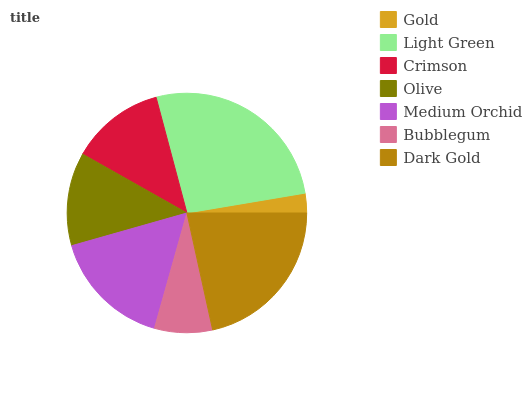Is Gold the minimum?
Answer yes or no. Yes. Is Light Green the maximum?
Answer yes or no. Yes. Is Crimson the minimum?
Answer yes or no. No. Is Crimson the maximum?
Answer yes or no. No. Is Light Green greater than Crimson?
Answer yes or no. Yes. Is Crimson less than Light Green?
Answer yes or no. Yes. Is Crimson greater than Light Green?
Answer yes or no. No. Is Light Green less than Crimson?
Answer yes or no. No. Is Crimson the high median?
Answer yes or no. Yes. Is Crimson the low median?
Answer yes or no. Yes. Is Bubblegum the high median?
Answer yes or no. No. Is Bubblegum the low median?
Answer yes or no. No. 